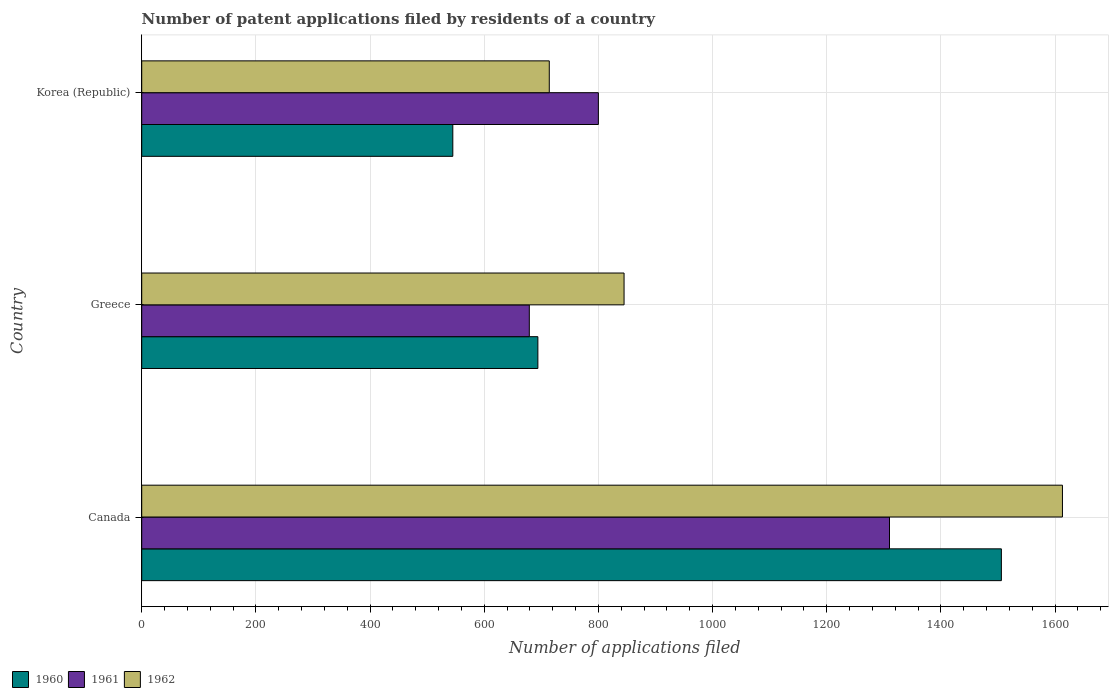How many different coloured bars are there?
Provide a short and direct response. 3. What is the number of applications filed in 1960 in Greece?
Make the answer very short. 694. Across all countries, what is the maximum number of applications filed in 1961?
Ensure brevity in your answer.  1310. Across all countries, what is the minimum number of applications filed in 1962?
Offer a terse response. 714. In which country was the number of applications filed in 1961 minimum?
Provide a short and direct response. Greece. What is the total number of applications filed in 1962 in the graph?
Give a very brief answer. 3172. What is the difference between the number of applications filed in 1962 in Canada and that in Greece?
Offer a terse response. 768. What is the difference between the number of applications filed in 1962 in Greece and the number of applications filed in 1960 in Canada?
Offer a very short reply. -661. What is the average number of applications filed in 1961 per country?
Provide a short and direct response. 929.67. What is the difference between the number of applications filed in 1960 and number of applications filed in 1961 in Korea (Republic)?
Your response must be concise. -255. In how many countries, is the number of applications filed in 1962 greater than 880 ?
Offer a very short reply. 1. What is the ratio of the number of applications filed in 1962 in Canada to that in Greece?
Your answer should be compact. 1.91. Is the number of applications filed in 1960 in Canada less than that in Korea (Republic)?
Provide a short and direct response. No. What is the difference between the highest and the second highest number of applications filed in 1961?
Provide a short and direct response. 510. What is the difference between the highest and the lowest number of applications filed in 1960?
Provide a short and direct response. 961. In how many countries, is the number of applications filed in 1961 greater than the average number of applications filed in 1961 taken over all countries?
Offer a terse response. 1. Is the sum of the number of applications filed in 1962 in Greece and Korea (Republic) greater than the maximum number of applications filed in 1960 across all countries?
Provide a short and direct response. Yes. What does the 3rd bar from the bottom in Korea (Republic) represents?
Offer a very short reply. 1962. Is it the case that in every country, the sum of the number of applications filed in 1961 and number of applications filed in 1960 is greater than the number of applications filed in 1962?
Keep it short and to the point. Yes. How many bars are there?
Your response must be concise. 9. How many countries are there in the graph?
Give a very brief answer. 3. What is the difference between two consecutive major ticks on the X-axis?
Your response must be concise. 200. Are the values on the major ticks of X-axis written in scientific E-notation?
Give a very brief answer. No. Does the graph contain any zero values?
Offer a very short reply. No. How are the legend labels stacked?
Your response must be concise. Horizontal. What is the title of the graph?
Ensure brevity in your answer.  Number of patent applications filed by residents of a country. Does "1983" appear as one of the legend labels in the graph?
Your response must be concise. No. What is the label or title of the X-axis?
Offer a terse response. Number of applications filed. What is the Number of applications filed of 1960 in Canada?
Make the answer very short. 1506. What is the Number of applications filed in 1961 in Canada?
Give a very brief answer. 1310. What is the Number of applications filed in 1962 in Canada?
Ensure brevity in your answer.  1613. What is the Number of applications filed of 1960 in Greece?
Make the answer very short. 694. What is the Number of applications filed in 1961 in Greece?
Provide a short and direct response. 679. What is the Number of applications filed of 1962 in Greece?
Your answer should be very brief. 845. What is the Number of applications filed of 1960 in Korea (Republic)?
Ensure brevity in your answer.  545. What is the Number of applications filed of 1961 in Korea (Republic)?
Your answer should be compact. 800. What is the Number of applications filed in 1962 in Korea (Republic)?
Offer a very short reply. 714. Across all countries, what is the maximum Number of applications filed in 1960?
Keep it short and to the point. 1506. Across all countries, what is the maximum Number of applications filed in 1961?
Keep it short and to the point. 1310. Across all countries, what is the maximum Number of applications filed in 1962?
Ensure brevity in your answer.  1613. Across all countries, what is the minimum Number of applications filed of 1960?
Your response must be concise. 545. Across all countries, what is the minimum Number of applications filed of 1961?
Offer a very short reply. 679. Across all countries, what is the minimum Number of applications filed of 1962?
Offer a very short reply. 714. What is the total Number of applications filed in 1960 in the graph?
Keep it short and to the point. 2745. What is the total Number of applications filed in 1961 in the graph?
Your answer should be very brief. 2789. What is the total Number of applications filed of 1962 in the graph?
Offer a very short reply. 3172. What is the difference between the Number of applications filed of 1960 in Canada and that in Greece?
Your response must be concise. 812. What is the difference between the Number of applications filed in 1961 in Canada and that in Greece?
Your response must be concise. 631. What is the difference between the Number of applications filed of 1962 in Canada and that in Greece?
Ensure brevity in your answer.  768. What is the difference between the Number of applications filed in 1960 in Canada and that in Korea (Republic)?
Give a very brief answer. 961. What is the difference between the Number of applications filed in 1961 in Canada and that in Korea (Republic)?
Your answer should be very brief. 510. What is the difference between the Number of applications filed of 1962 in Canada and that in Korea (Republic)?
Your response must be concise. 899. What is the difference between the Number of applications filed of 1960 in Greece and that in Korea (Republic)?
Offer a very short reply. 149. What is the difference between the Number of applications filed in 1961 in Greece and that in Korea (Republic)?
Keep it short and to the point. -121. What is the difference between the Number of applications filed of 1962 in Greece and that in Korea (Republic)?
Offer a terse response. 131. What is the difference between the Number of applications filed in 1960 in Canada and the Number of applications filed in 1961 in Greece?
Keep it short and to the point. 827. What is the difference between the Number of applications filed in 1960 in Canada and the Number of applications filed in 1962 in Greece?
Your response must be concise. 661. What is the difference between the Number of applications filed in 1961 in Canada and the Number of applications filed in 1962 in Greece?
Keep it short and to the point. 465. What is the difference between the Number of applications filed of 1960 in Canada and the Number of applications filed of 1961 in Korea (Republic)?
Provide a short and direct response. 706. What is the difference between the Number of applications filed of 1960 in Canada and the Number of applications filed of 1962 in Korea (Republic)?
Your response must be concise. 792. What is the difference between the Number of applications filed of 1961 in Canada and the Number of applications filed of 1962 in Korea (Republic)?
Offer a terse response. 596. What is the difference between the Number of applications filed of 1960 in Greece and the Number of applications filed of 1961 in Korea (Republic)?
Ensure brevity in your answer.  -106. What is the difference between the Number of applications filed of 1960 in Greece and the Number of applications filed of 1962 in Korea (Republic)?
Ensure brevity in your answer.  -20. What is the difference between the Number of applications filed of 1961 in Greece and the Number of applications filed of 1962 in Korea (Republic)?
Make the answer very short. -35. What is the average Number of applications filed in 1960 per country?
Provide a succinct answer. 915. What is the average Number of applications filed of 1961 per country?
Your answer should be very brief. 929.67. What is the average Number of applications filed in 1962 per country?
Offer a very short reply. 1057.33. What is the difference between the Number of applications filed of 1960 and Number of applications filed of 1961 in Canada?
Give a very brief answer. 196. What is the difference between the Number of applications filed in 1960 and Number of applications filed in 1962 in Canada?
Make the answer very short. -107. What is the difference between the Number of applications filed in 1961 and Number of applications filed in 1962 in Canada?
Offer a terse response. -303. What is the difference between the Number of applications filed in 1960 and Number of applications filed in 1962 in Greece?
Provide a short and direct response. -151. What is the difference between the Number of applications filed in 1961 and Number of applications filed in 1962 in Greece?
Keep it short and to the point. -166. What is the difference between the Number of applications filed of 1960 and Number of applications filed of 1961 in Korea (Republic)?
Provide a succinct answer. -255. What is the difference between the Number of applications filed of 1960 and Number of applications filed of 1962 in Korea (Republic)?
Your answer should be compact. -169. What is the difference between the Number of applications filed of 1961 and Number of applications filed of 1962 in Korea (Republic)?
Offer a very short reply. 86. What is the ratio of the Number of applications filed of 1960 in Canada to that in Greece?
Ensure brevity in your answer.  2.17. What is the ratio of the Number of applications filed in 1961 in Canada to that in Greece?
Make the answer very short. 1.93. What is the ratio of the Number of applications filed in 1962 in Canada to that in Greece?
Provide a succinct answer. 1.91. What is the ratio of the Number of applications filed of 1960 in Canada to that in Korea (Republic)?
Your response must be concise. 2.76. What is the ratio of the Number of applications filed of 1961 in Canada to that in Korea (Republic)?
Provide a short and direct response. 1.64. What is the ratio of the Number of applications filed of 1962 in Canada to that in Korea (Republic)?
Your response must be concise. 2.26. What is the ratio of the Number of applications filed in 1960 in Greece to that in Korea (Republic)?
Give a very brief answer. 1.27. What is the ratio of the Number of applications filed of 1961 in Greece to that in Korea (Republic)?
Make the answer very short. 0.85. What is the ratio of the Number of applications filed in 1962 in Greece to that in Korea (Republic)?
Give a very brief answer. 1.18. What is the difference between the highest and the second highest Number of applications filed in 1960?
Provide a short and direct response. 812. What is the difference between the highest and the second highest Number of applications filed of 1961?
Provide a short and direct response. 510. What is the difference between the highest and the second highest Number of applications filed in 1962?
Your answer should be very brief. 768. What is the difference between the highest and the lowest Number of applications filed of 1960?
Give a very brief answer. 961. What is the difference between the highest and the lowest Number of applications filed of 1961?
Provide a succinct answer. 631. What is the difference between the highest and the lowest Number of applications filed of 1962?
Your answer should be very brief. 899. 